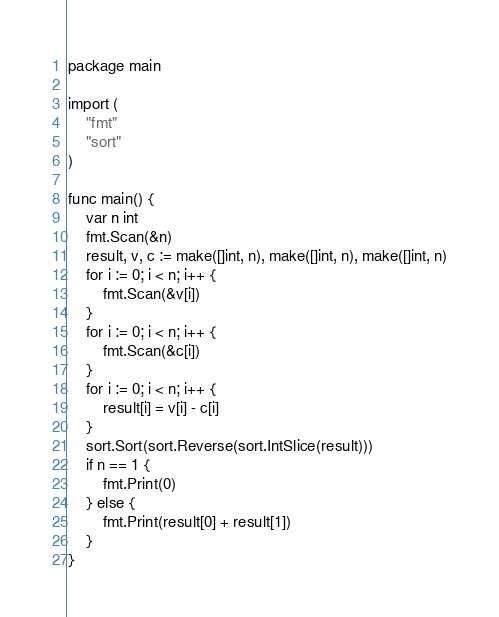Convert code to text. <code><loc_0><loc_0><loc_500><loc_500><_Go_>package main

import (
	"fmt"
	"sort"
)

func main() {
	var n int
	fmt.Scan(&n)
	result, v, c := make([]int, n), make([]int, n), make([]int, n)
	for i := 0; i < n; i++ {
		fmt.Scan(&v[i])
	}
	for i := 0; i < n; i++ {
		fmt.Scan(&c[i])
	}
	for i := 0; i < n; i++ {
		result[i] = v[i] - c[i]
	}
	sort.Sort(sort.Reverse(sort.IntSlice(result)))
	if n == 1 {
		fmt.Print(0)
	} else {
		fmt.Print(result[0] + result[1])
	}
}
</code> 